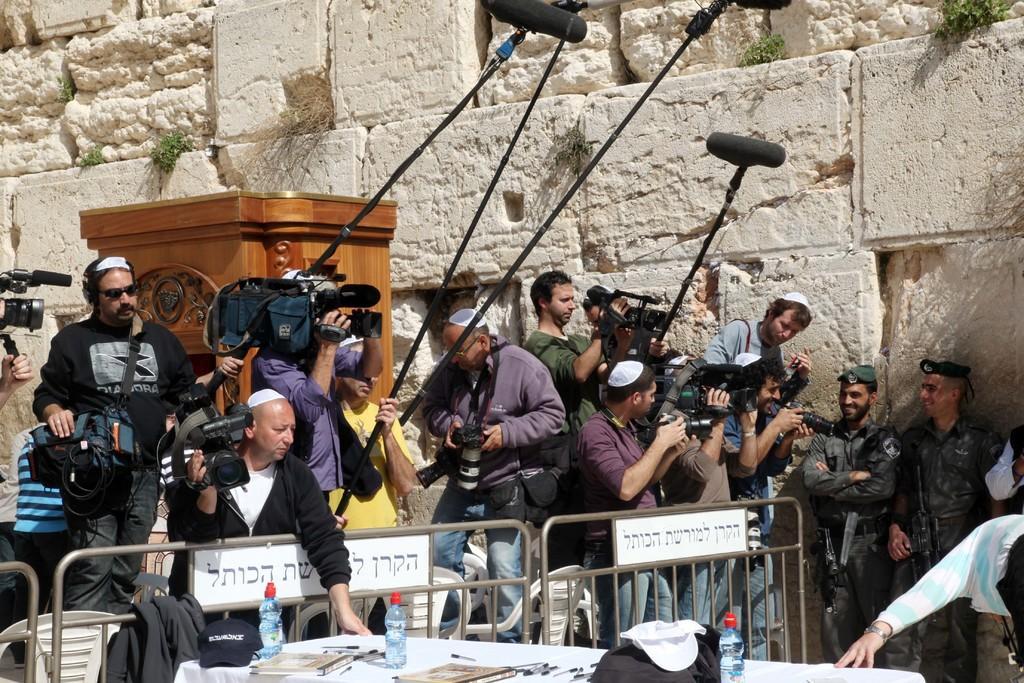Can you describe this image briefly? In the center of the image we can see persons standing at the fence and holding a video camera and mics. On the right side of the image we can see persons standing at the wall wearing caps. At the bottom of the image we can see table, bottles, books and pens. In the background there is wall. 